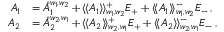<formula> <loc_0><loc_0><loc_500><loc_500>\begin{array} { r l } { A _ { 1 } } & { = \mathring { A } _ { 1 } ^ { w _ { 1 } , w _ { 2 } } + \langle \, \langle A _ { 1 } \rangle \, \rangle _ { w _ { 1 } , w _ { 2 } } ^ { + } E _ { + } + \langle \, \langle A _ { 1 } \rangle \, \rangle _ { w _ { 1 } , w _ { 2 } } ^ { - } E _ { - } \, , } \\ { A _ { 2 } } & { = \mathring { A } _ { 2 } ^ { w _ { 2 } , w _ { 1 } } + \langle \, \langle A _ { 2 } \rangle \, \rangle _ { w _ { 2 } , w _ { 1 } } ^ { + } E _ { + } + \langle \, \langle A _ { 2 } \rangle \, \rangle _ { w _ { 2 } , w _ { 1 } } ^ { - } E _ { - } \, , } \end{array}</formula> 